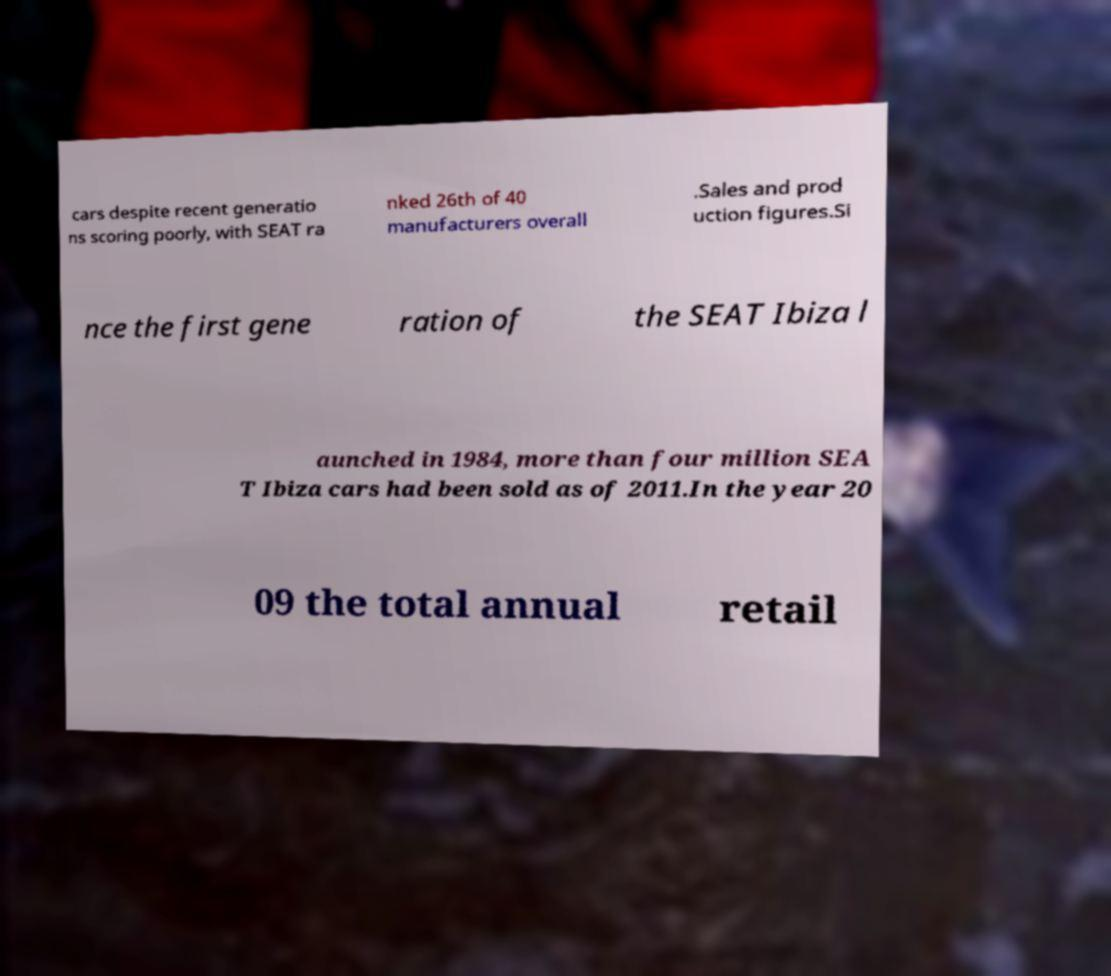Can you accurately transcribe the text from the provided image for me? cars despite recent generatio ns scoring poorly, with SEAT ra nked 26th of 40 manufacturers overall .Sales and prod uction figures.Si nce the first gene ration of the SEAT Ibiza l aunched in 1984, more than four million SEA T Ibiza cars had been sold as of 2011.In the year 20 09 the total annual retail 